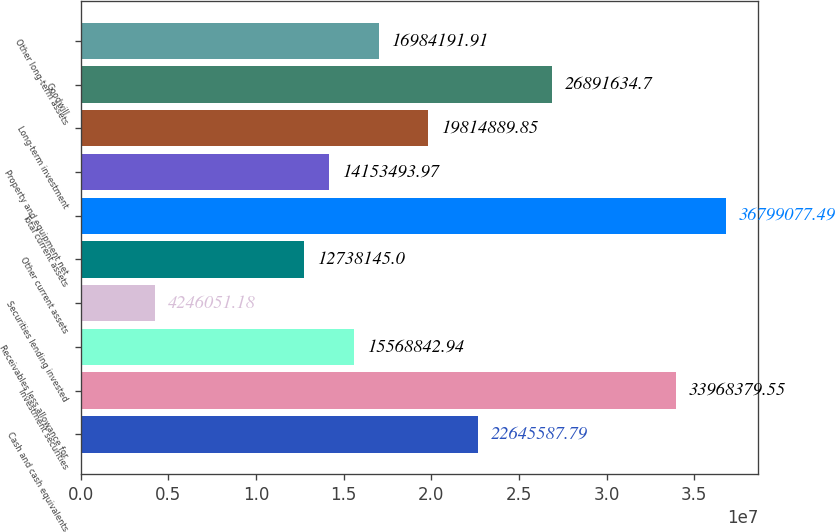Convert chart to OTSL. <chart><loc_0><loc_0><loc_500><loc_500><bar_chart><fcel>Cash and cash equivalents<fcel>Investment securities<fcel>Receivables less allowance for<fcel>Securities lending invested<fcel>Other current assets<fcel>Total current assets<fcel>Property and equipment net<fcel>Long-term investment<fcel>Goodwill<fcel>Other long-term assets<nl><fcel>2.26456e+07<fcel>3.39684e+07<fcel>1.55688e+07<fcel>4.24605e+06<fcel>1.27381e+07<fcel>3.67991e+07<fcel>1.41535e+07<fcel>1.98149e+07<fcel>2.68916e+07<fcel>1.69842e+07<nl></chart> 